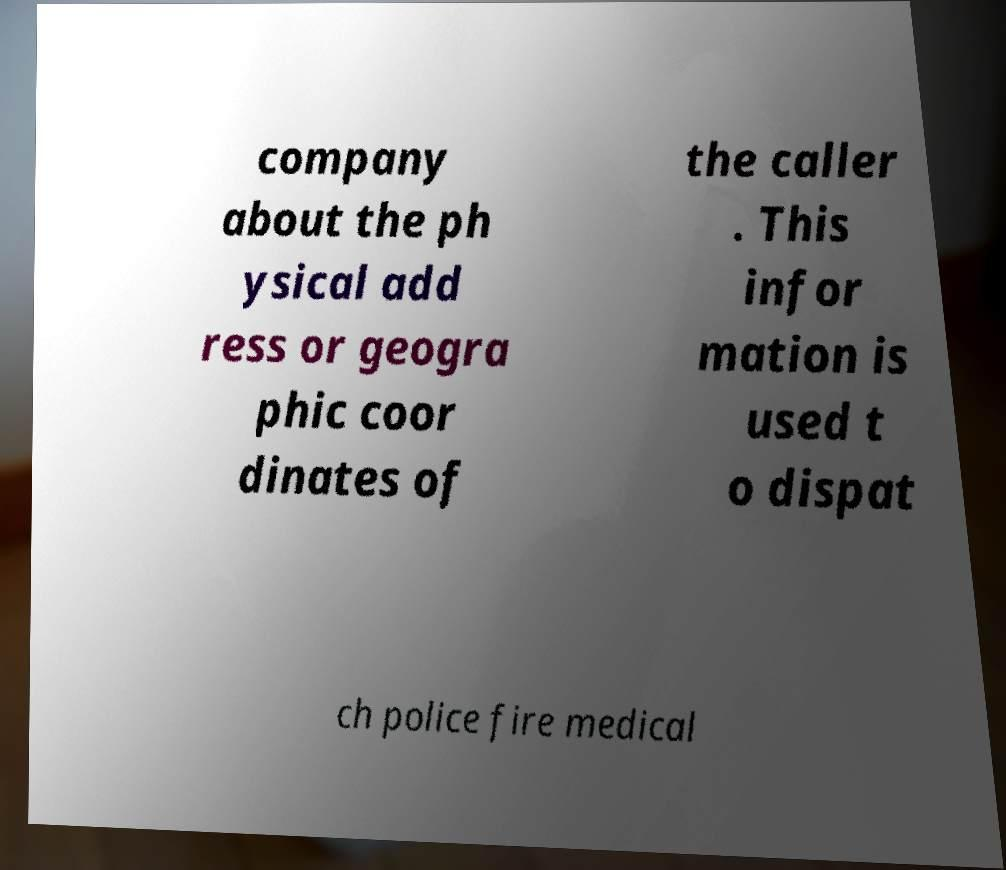Could you assist in decoding the text presented in this image and type it out clearly? company about the ph ysical add ress or geogra phic coor dinates of the caller . This infor mation is used t o dispat ch police fire medical 